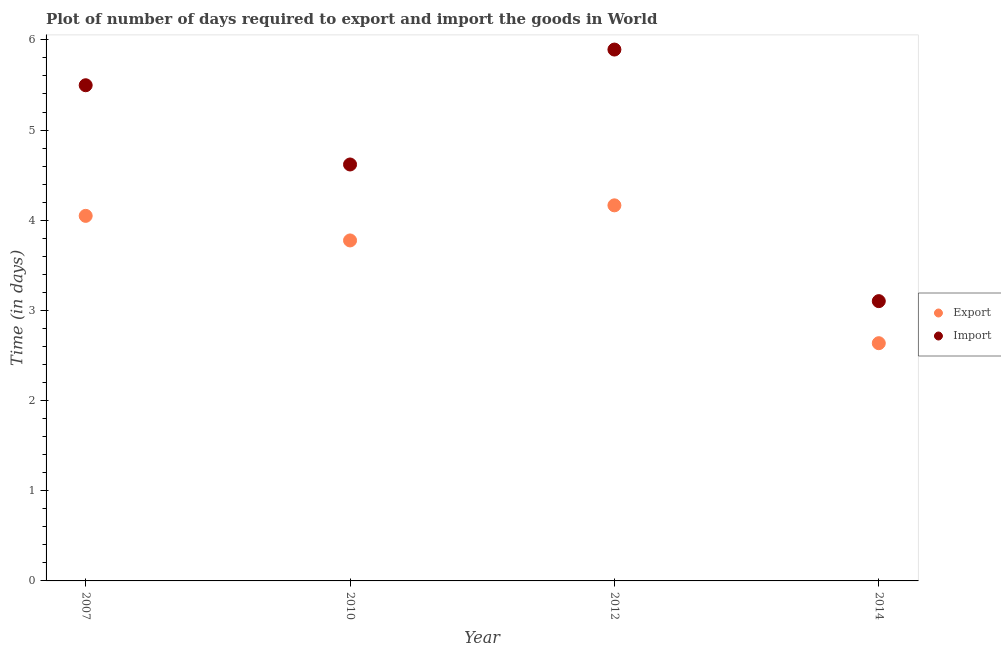How many different coloured dotlines are there?
Offer a terse response. 2. What is the time required to export in 2010?
Your response must be concise. 3.78. Across all years, what is the maximum time required to export?
Give a very brief answer. 4.17. Across all years, what is the minimum time required to import?
Offer a very short reply. 3.1. In which year was the time required to import maximum?
Offer a very short reply. 2012. What is the total time required to export in the graph?
Your answer should be very brief. 14.63. What is the difference between the time required to import in 2012 and that in 2014?
Provide a succinct answer. 2.79. What is the difference between the time required to import in 2010 and the time required to export in 2012?
Offer a very short reply. 0.45. What is the average time required to export per year?
Make the answer very short. 3.66. In the year 2007, what is the difference between the time required to import and time required to export?
Keep it short and to the point. 1.45. In how many years, is the time required to import greater than 5.4 days?
Provide a succinct answer. 2. What is the ratio of the time required to export in 2007 to that in 2010?
Offer a very short reply. 1.07. Is the difference between the time required to import in 2010 and 2012 greater than the difference between the time required to export in 2010 and 2012?
Make the answer very short. No. What is the difference between the highest and the second highest time required to import?
Keep it short and to the point. 0.4. What is the difference between the highest and the lowest time required to import?
Provide a succinct answer. 2.79. Is the sum of the time required to export in 2010 and 2014 greater than the maximum time required to import across all years?
Provide a succinct answer. Yes. Does the time required to export monotonically increase over the years?
Offer a very short reply. No. Is the time required to import strictly less than the time required to export over the years?
Keep it short and to the point. No. How many dotlines are there?
Provide a short and direct response. 2. How many years are there in the graph?
Make the answer very short. 4. What is the difference between two consecutive major ticks on the Y-axis?
Your answer should be very brief. 1. Are the values on the major ticks of Y-axis written in scientific E-notation?
Make the answer very short. No. How many legend labels are there?
Offer a very short reply. 2. What is the title of the graph?
Give a very brief answer. Plot of number of days required to export and import the goods in World. Does "Time to import" appear as one of the legend labels in the graph?
Your answer should be very brief. No. What is the label or title of the Y-axis?
Offer a terse response. Time (in days). What is the Time (in days) of Export in 2007?
Your response must be concise. 4.05. What is the Time (in days) of Import in 2007?
Make the answer very short. 5.5. What is the Time (in days) of Export in 2010?
Make the answer very short. 3.78. What is the Time (in days) in Import in 2010?
Your response must be concise. 4.62. What is the Time (in days) of Export in 2012?
Keep it short and to the point. 4.17. What is the Time (in days) of Import in 2012?
Your response must be concise. 5.89. What is the Time (in days) in Export in 2014?
Give a very brief answer. 2.64. What is the Time (in days) in Import in 2014?
Ensure brevity in your answer.  3.1. Across all years, what is the maximum Time (in days) in Export?
Offer a very short reply. 4.17. Across all years, what is the maximum Time (in days) in Import?
Provide a succinct answer. 5.89. Across all years, what is the minimum Time (in days) in Export?
Provide a succinct answer. 2.64. Across all years, what is the minimum Time (in days) of Import?
Offer a very short reply. 3.1. What is the total Time (in days) in Export in the graph?
Provide a short and direct response. 14.63. What is the total Time (in days) in Import in the graph?
Your answer should be very brief. 19.11. What is the difference between the Time (in days) of Export in 2007 and that in 2010?
Offer a very short reply. 0.27. What is the difference between the Time (in days) of Import in 2007 and that in 2010?
Provide a succinct answer. 0.88. What is the difference between the Time (in days) in Export in 2007 and that in 2012?
Ensure brevity in your answer.  -0.12. What is the difference between the Time (in days) in Import in 2007 and that in 2012?
Your answer should be compact. -0.4. What is the difference between the Time (in days) in Export in 2007 and that in 2014?
Give a very brief answer. 1.41. What is the difference between the Time (in days) of Import in 2007 and that in 2014?
Offer a very short reply. 2.39. What is the difference between the Time (in days) of Export in 2010 and that in 2012?
Your answer should be very brief. -0.39. What is the difference between the Time (in days) in Import in 2010 and that in 2012?
Offer a terse response. -1.27. What is the difference between the Time (in days) of Export in 2010 and that in 2014?
Provide a short and direct response. 1.14. What is the difference between the Time (in days) of Import in 2010 and that in 2014?
Make the answer very short. 1.52. What is the difference between the Time (in days) of Export in 2012 and that in 2014?
Provide a succinct answer. 1.53. What is the difference between the Time (in days) in Import in 2012 and that in 2014?
Offer a terse response. 2.79. What is the difference between the Time (in days) in Export in 2007 and the Time (in days) in Import in 2010?
Provide a succinct answer. -0.57. What is the difference between the Time (in days) of Export in 2007 and the Time (in days) of Import in 2012?
Your response must be concise. -1.84. What is the difference between the Time (in days) of Export in 2007 and the Time (in days) of Import in 2014?
Offer a terse response. 0.95. What is the difference between the Time (in days) of Export in 2010 and the Time (in days) of Import in 2012?
Offer a terse response. -2.12. What is the difference between the Time (in days) in Export in 2010 and the Time (in days) in Import in 2014?
Your answer should be compact. 0.67. What is the difference between the Time (in days) in Export in 2012 and the Time (in days) in Import in 2014?
Keep it short and to the point. 1.06. What is the average Time (in days) of Export per year?
Your answer should be very brief. 3.66. What is the average Time (in days) of Import per year?
Offer a very short reply. 4.78. In the year 2007, what is the difference between the Time (in days) of Export and Time (in days) of Import?
Make the answer very short. -1.45. In the year 2010, what is the difference between the Time (in days) of Export and Time (in days) of Import?
Your answer should be compact. -0.84. In the year 2012, what is the difference between the Time (in days) in Export and Time (in days) in Import?
Make the answer very short. -1.73. In the year 2014, what is the difference between the Time (in days) of Export and Time (in days) of Import?
Keep it short and to the point. -0.47. What is the ratio of the Time (in days) of Export in 2007 to that in 2010?
Provide a short and direct response. 1.07. What is the ratio of the Time (in days) of Import in 2007 to that in 2010?
Offer a very short reply. 1.19. What is the ratio of the Time (in days) of Import in 2007 to that in 2012?
Make the answer very short. 0.93. What is the ratio of the Time (in days) of Export in 2007 to that in 2014?
Provide a succinct answer. 1.54. What is the ratio of the Time (in days) of Import in 2007 to that in 2014?
Your answer should be compact. 1.77. What is the ratio of the Time (in days) of Export in 2010 to that in 2012?
Make the answer very short. 0.91. What is the ratio of the Time (in days) of Import in 2010 to that in 2012?
Keep it short and to the point. 0.78. What is the ratio of the Time (in days) in Export in 2010 to that in 2014?
Offer a terse response. 1.43. What is the ratio of the Time (in days) of Import in 2010 to that in 2014?
Make the answer very short. 1.49. What is the ratio of the Time (in days) of Export in 2012 to that in 2014?
Your answer should be compact. 1.58. What is the ratio of the Time (in days) in Import in 2012 to that in 2014?
Provide a succinct answer. 1.9. What is the difference between the highest and the second highest Time (in days) of Export?
Provide a succinct answer. 0.12. What is the difference between the highest and the second highest Time (in days) in Import?
Offer a very short reply. 0.4. What is the difference between the highest and the lowest Time (in days) of Export?
Your response must be concise. 1.53. What is the difference between the highest and the lowest Time (in days) in Import?
Your response must be concise. 2.79. 